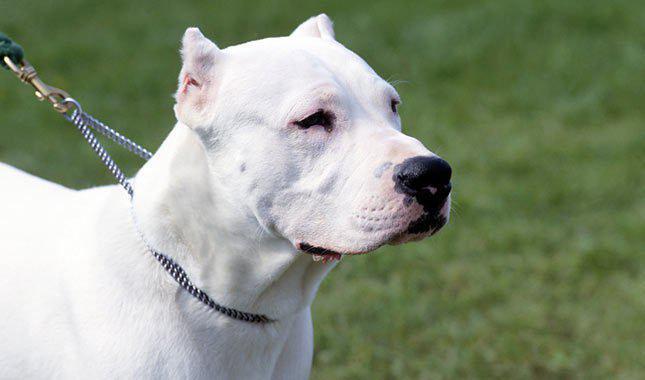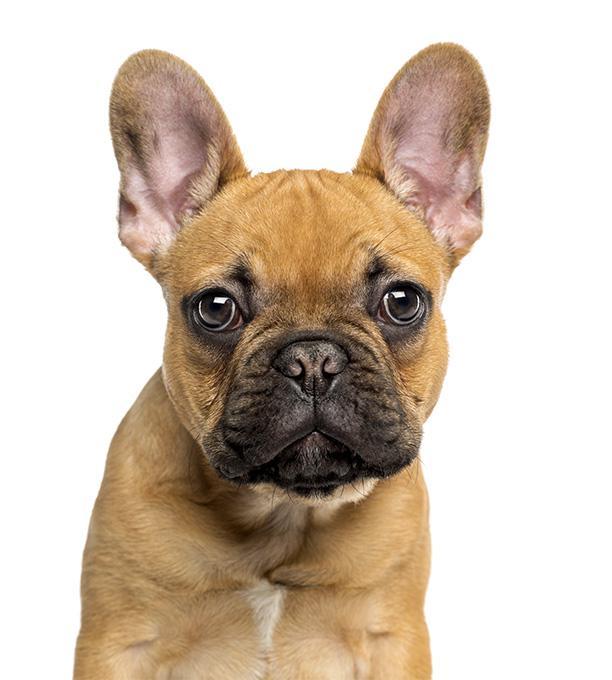The first image is the image on the left, the second image is the image on the right. For the images shown, is this caption "At least one dog has black fur on an ear." true? Answer yes or no. No. 